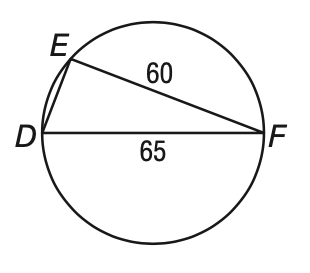Question: What is E D?
Choices:
A. 15
B. 25
C. 88.5
D. not enough information
Answer with the letter. Answer: D 